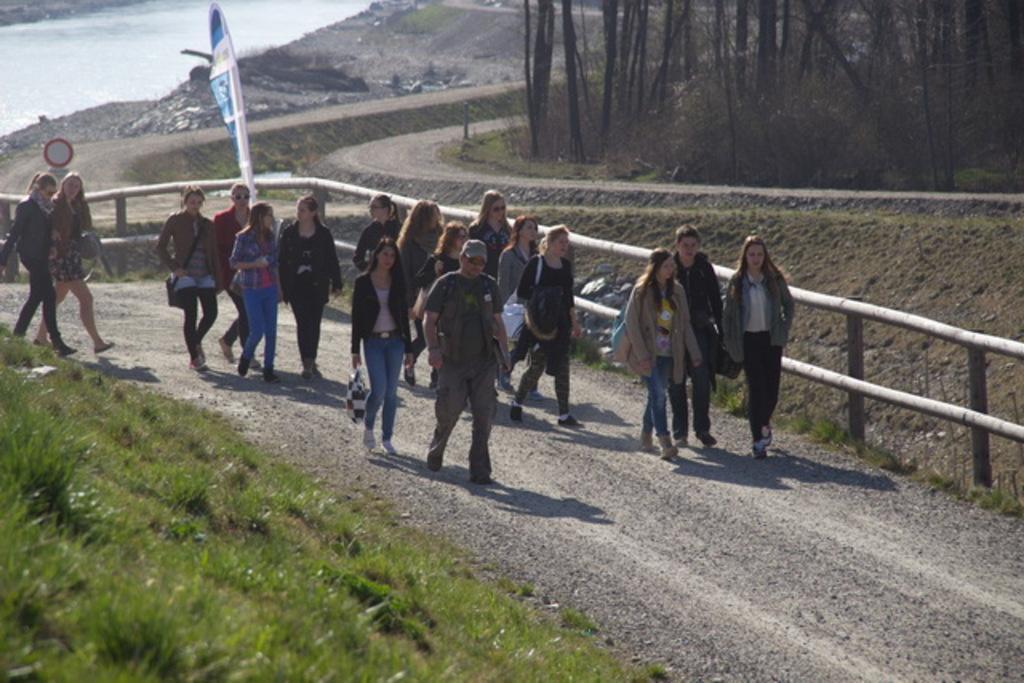Describe this image in one or two sentences. In the image we can see there are people standing on the road and the ground is covered with grass. Behind there are trees and there is water. 